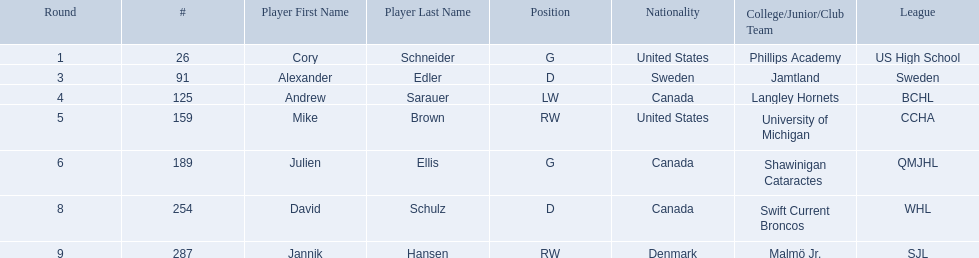Who are all the players? Cory Schneider (G), Alexander Edler (D), Andrew Sarauer (LW), Mike Brown (RW), Julien Ellis (G), David Schulz (D), Jannik Hansen (RW). What is the nationality of each player? United States, Sweden, Canada, United States, Canada, Canada, Denmark. Where did they attend school? Phillips Academy (US High School), Jamtland (Sweden), Langley Hornets (BCHL), University of Michigan (CCHA), Shawinigan Cataractes (QMJHL), Swift Current Broncos (WHL), Malmö Jr. (SJL). Which player attended langley hornets? Andrew Sarauer (LW). 